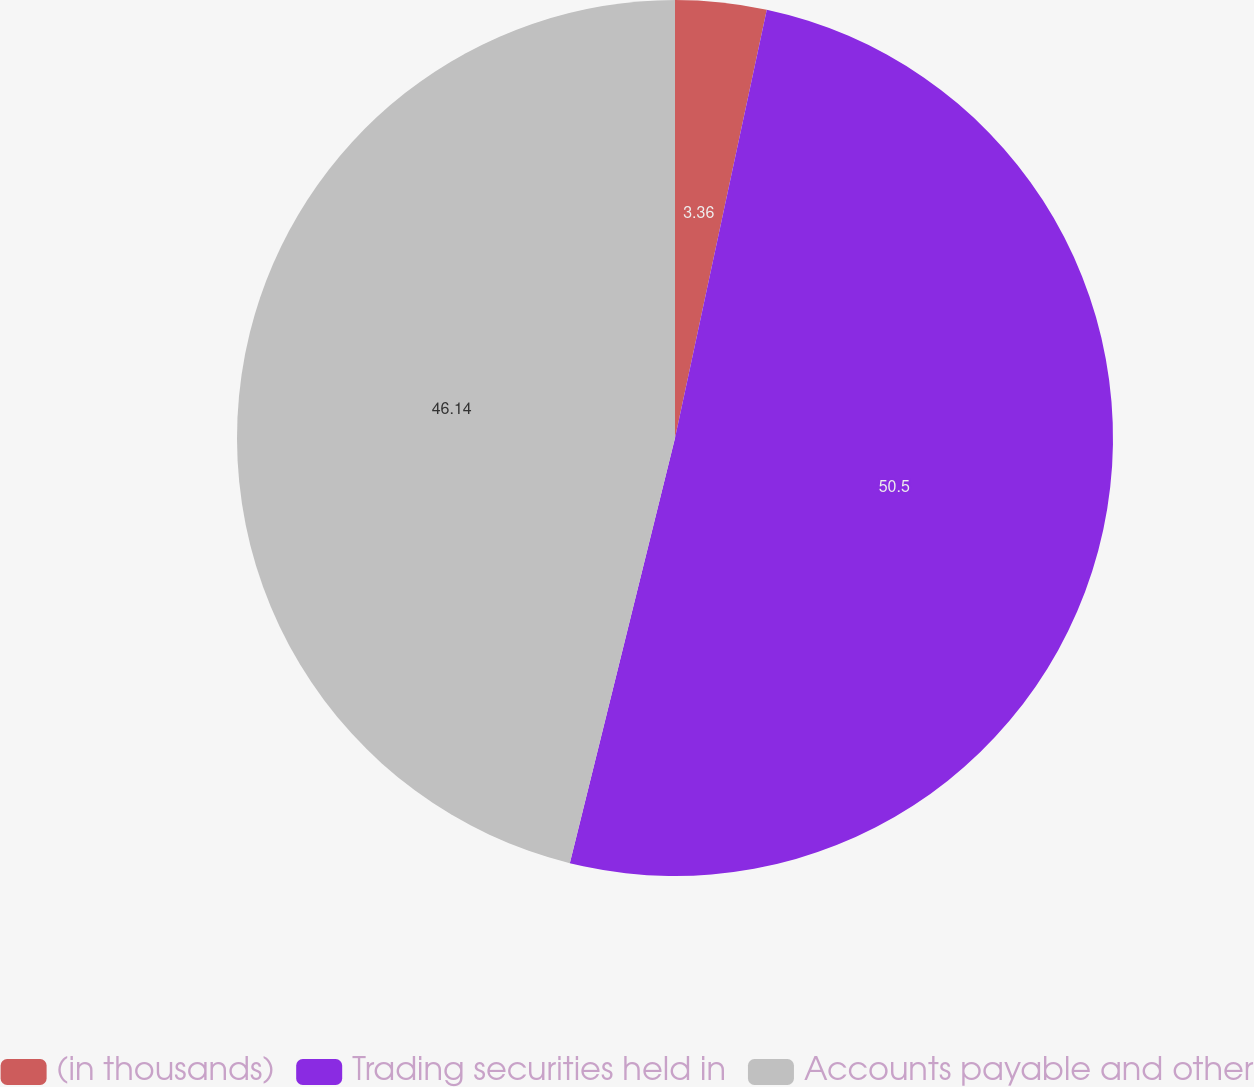<chart> <loc_0><loc_0><loc_500><loc_500><pie_chart><fcel>(in thousands)<fcel>Trading securities held in<fcel>Accounts payable and other<nl><fcel>3.36%<fcel>50.5%<fcel>46.14%<nl></chart> 